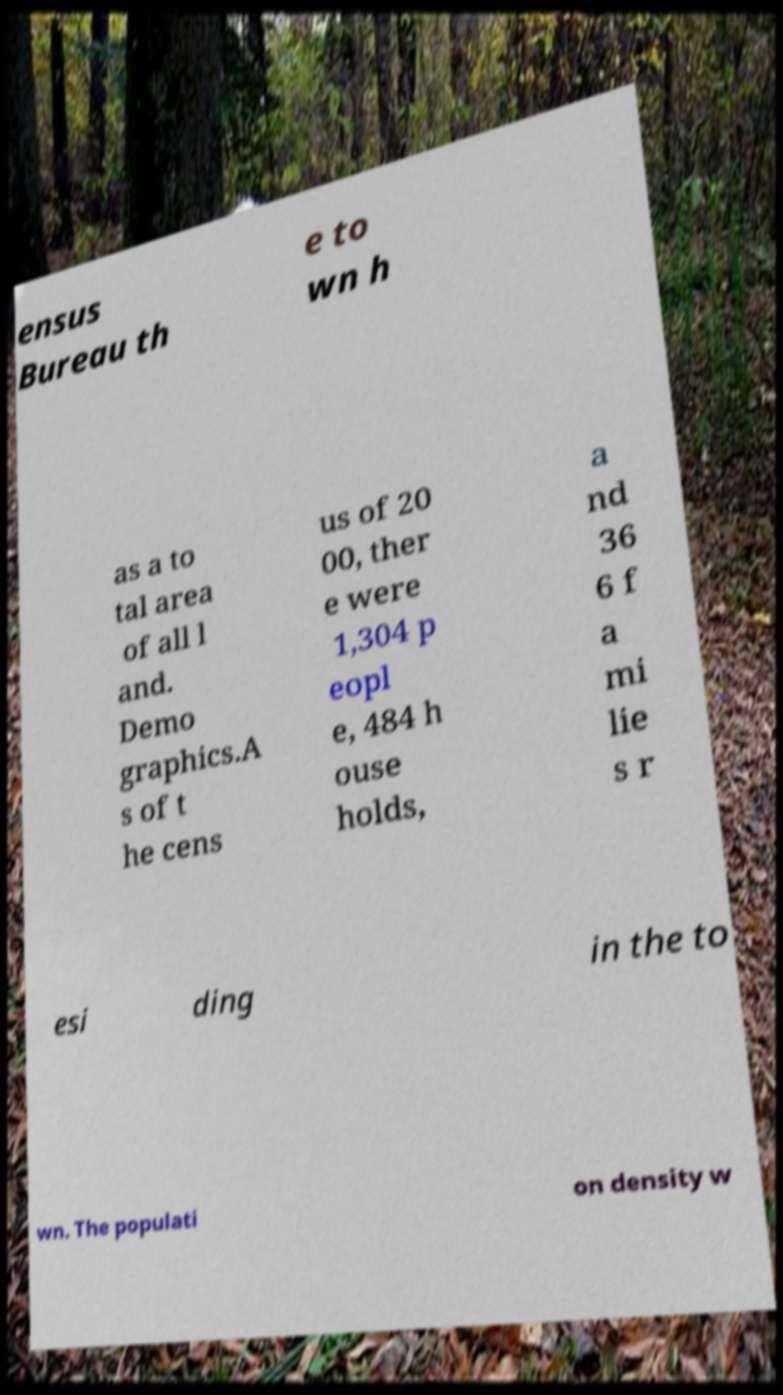Could you assist in decoding the text presented in this image and type it out clearly? ensus Bureau th e to wn h as a to tal area of all l and. Demo graphics.A s of t he cens us of 20 00, ther e were 1,304 p eopl e, 484 h ouse holds, a nd 36 6 f a mi lie s r esi ding in the to wn. The populati on density w 